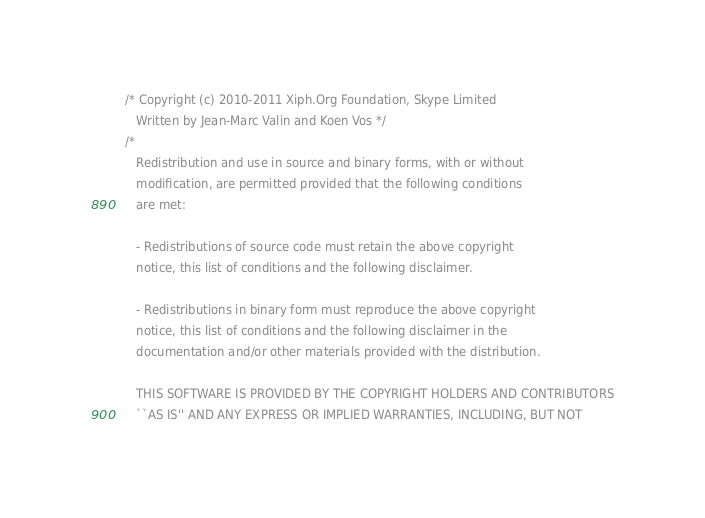Convert code to text. <code><loc_0><loc_0><loc_500><loc_500><_C_>/* Copyright (c) 2010-2011 Xiph.Org Foundation, Skype Limited
   Written by Jean-Marc Valin and Koen Vos */
/*
   Redistribution and use in source and binary forms, with or without
   modification, are permitted provided that the following conditions
   are met:

   - Redistributions of source code must retain the above copyright
   notice, this list of conditions and the following disclaimer.

   - Redistributions in binary form must reproduce the above copyright
   notice, this list of conditions and the following disclaimer in the
   documentation and/or other materials provided with the distribution.

   THIS SOFTWARE IS PROVIDED BY THE COPYRIGHT HOLDERS AND CONTRIBUTORS
   ``AS IS'' AND ANY EXPRESS OR IMPLIED WARRANTIES, INCLUDING, BUT NOT</code> 